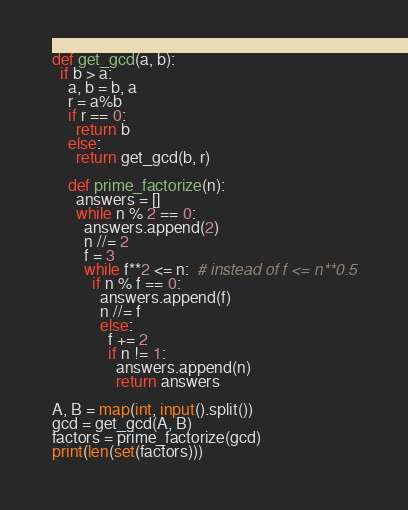<code> <loc_0><loc_0><loc_500><loc_500><_Python_>def get_gcd(a, b):
  if b > a:
    a, b = b, a
    r = a%b
    if r == 0:
      return b
    else:
      return get_gcd(b, r)

    def prime_factorize(n):
      answers = []
      while n % 2 == 0:
        answers.append(2)
        n //= 2
        f = 3
        while f**2 <= n:  # instead of f <= n**0.5
          if n % f == 0:
            answers.append(f)
            n //= f
            else:
              f += 2
              if n != 1:
                answers.append(n)
                return answers

A, B = map(int, input().split())
gcd = get_gcd(A, B)
factors = prime_factorize(gcd)
print(len(set(factors)))</code> 